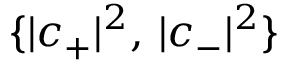Convert formula to latex. <formula><loc_0><loc_0><loc_500><loc_500>\{ | c _ { + } | ^ { 2 } , \, | c _ { - } | ^ { 2 } \}</formula> 